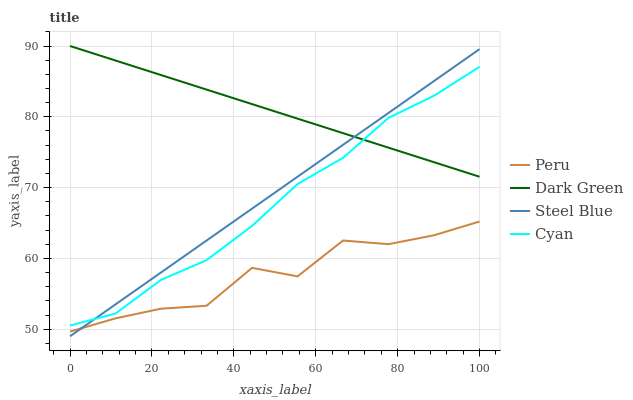Does Peru have the minimum area under the curve?
Answer yes or no. Yes. Does Dark Green have the maximum area under the curve?
Answer yes or no. Yes. Does Steel Blue have the minimum area under the curve?
Answer yes or no. No. Does Steel Blue have the maximum area under the curve?
Answer yes or no. No. Is Steel Blue the smoothest?
Answer yes or no. Yes. Is Peru the roughest?
Answer yes or no. Yes. Is Peru the smoothest?
Answer yes or no. No. Is Steel Blue the roughest?
Answer yes or no. No. Does Steel Blue have the lowest value?
Answer yes or no. Yes. Does Peru have the lowest value?
Answer yes or no. No. Does Dark Green have the highest value?
Answer yes or no. Yes. Does Steel Blue have the highest value?
Answer yes or no. No. Is Peru less than Cyan?
Answer yes or no. Yes. Is Dark Green greater than Peru?
Answer yes or no. Yes. Does Cyan intersect Steel Blue?
Answer yes or no. Yes. Is Cyan less than Steel Blue?
Answer yes or no. No. Is Cyan greater than Steel Blue?
Answer yes or no. No. Does Peru intersect Cyan?
Answer yes or no. No. 